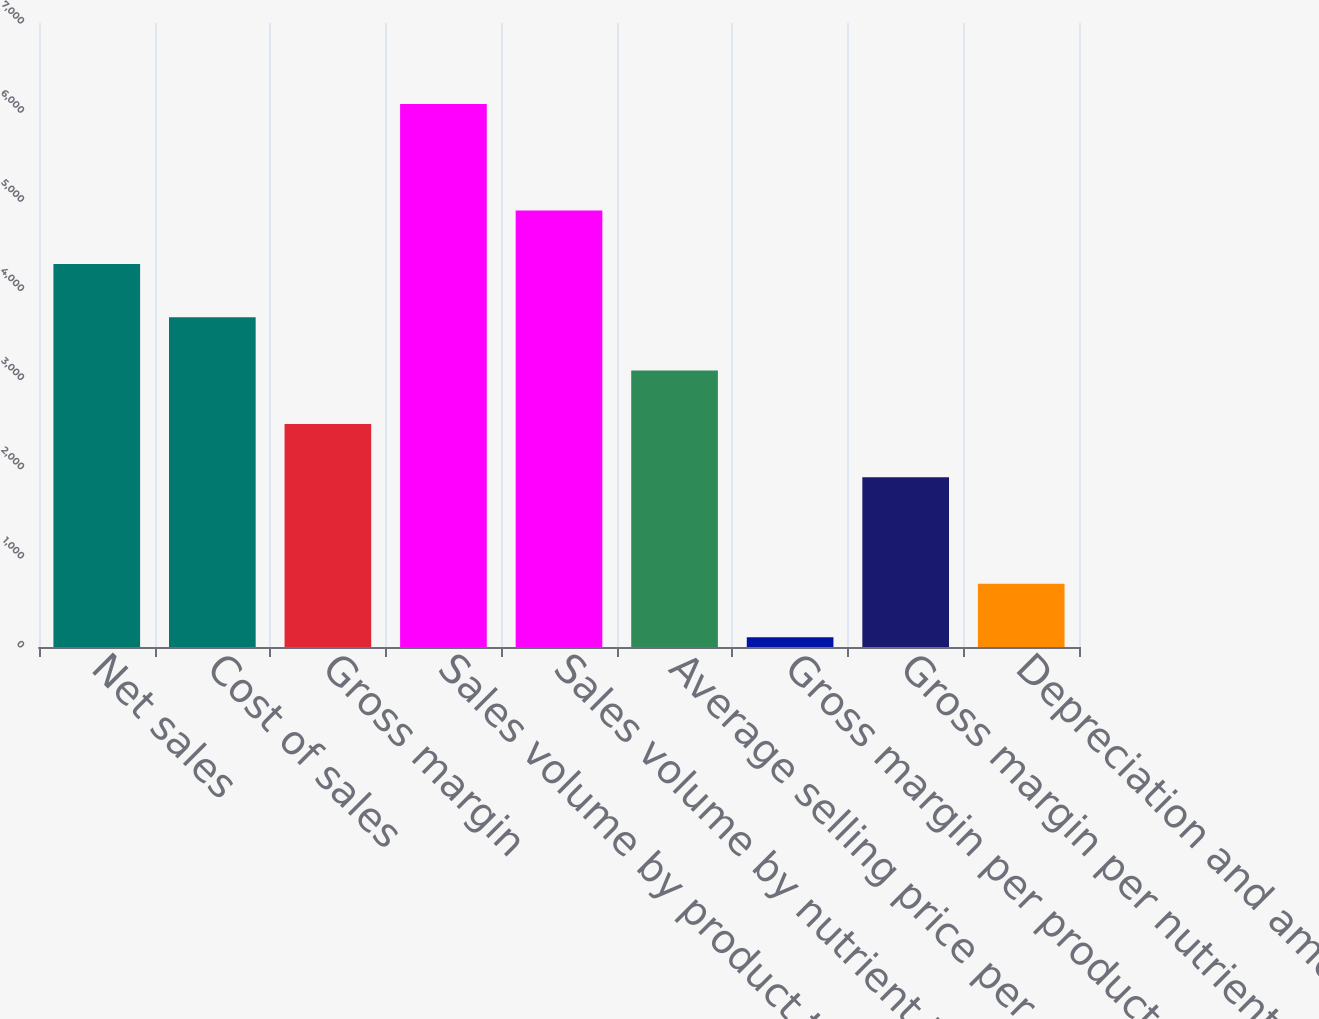Convert chart. <chart><loc_0><loc_0><loc_500><loc_500><bar_chart><fcel>Net sales<fcel>Cost of sales<fcel>Gross margin<fcel>Sales volume by product tons<fcel>Sales volume by nutrient tons<fcel>Average selling price per<fcel>Gross margin per product ton<fcel>Gross margin per nutrient ton<fcel>Depreciation and amortization<nl><fcel>4297.4<fcel>3699.2<fcel>2502.8<fcel>6092<fcel>4895.6<fcel>3101<fcel>110<fcel>1904.6<fcel>708.2<nl></chart> 